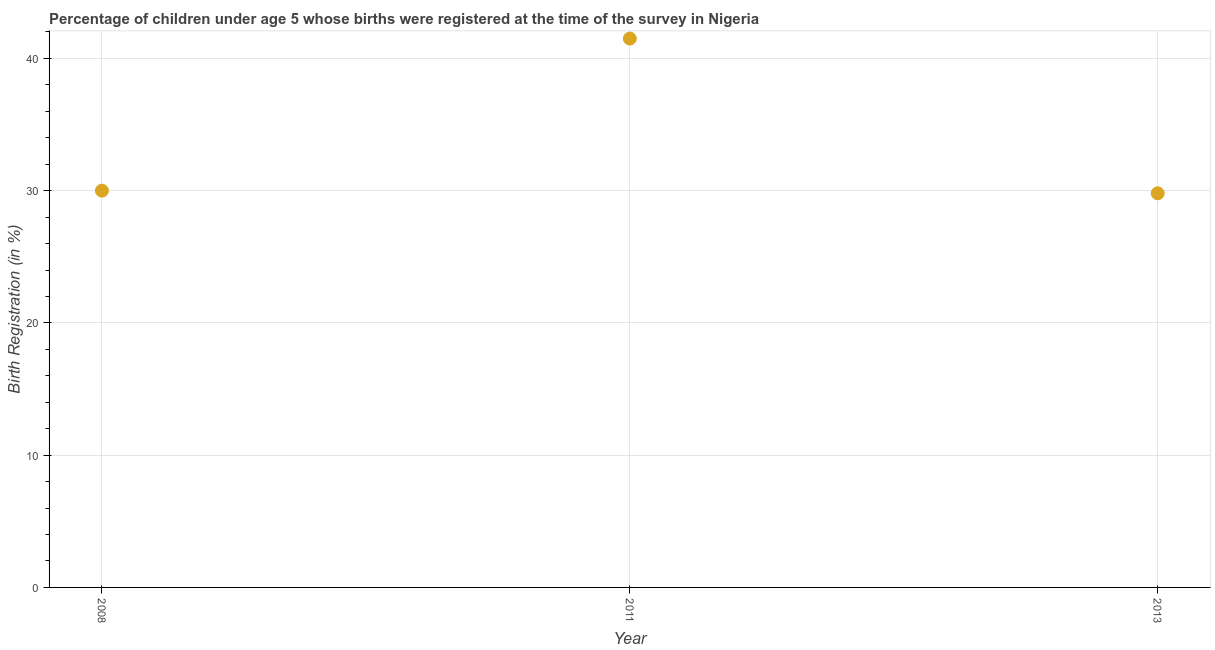What is the birth registration in 2011?
Your answer should be very brief. 41.5. Across all years, what is the maximum birth registration?
Your response must be concise. 41.5. Across all years, what is the minimum birth registration?
Your answer should be compact. 29.8. In which year was the birth registration maximum?
Provide a succinct answer. 2011. What is the sum of the birth registration?
Your answer should be very brief. 101.3. What is the difference between the birth registration in 2008 and 2013?
Provide a succinct answer. 0.2. What is the average birth registration per year?
Your response must be concise. 33.77. Do a majority of the years between 2011 and 2008 (inclusive) have birth registration greater than 2 %?
Keep it short and to the point. No. What is the ratio of the birth registration in 2008 to that in 2013?
Give a very brief answer. 1.01. Is the birth registration in 2008 less than that in 2011?
Your response must be concise. Yes. Is the difference between the birth registration in 2008 and 2013 greater than the difference between any two years?
Your answer should be very brief. No. Is the sum of the birth registration in 2011 and 2013 greater than the maximum birth registration across all years?
Offer a very short reply. Yes. In how many years, is the birth registration greater than the average birth registration taken over all years?
Offer a terse response. 1. How many years are there in the graph?
Provide a short and direct response. 3. What is the difference between two consecutive major ticks on the Y-axis?
Provide a short and direct response. 10. Does the graph contain any zero values?
Make the answer very short. No. What is the title of the graph?
Your answer should be very brief. Percentage of children under age 5 whose births were registered at the time of the survey in Nigeria. What is the label or title of the X-axis?
Your answer should be compact. Year. What is the label or title of the Y-axis?
Offer a very short reply. Birth Registration (in %). What is the Birth Registration (in %) in 2008?
Give a very brief answer. 30. What is the Birth Registration (in %) in 2011?
Provide a succinct answer. 41.5. What is the Birth Registration (in %) in 2013?
Provide a succinct answer. 29.8. What is the difference between the Birth Registration (in %) in 2011 and 2013?
Make the answer very short. 11.7. What is the ratio of the Birth Registration (in %) in 2008 to that in 2011?
Keep it short and to the point. 0.72. What is the ratio of the Birth Registration (in %) in 2011 to that in 2013?
Provide a short and direct response. 1.39. 